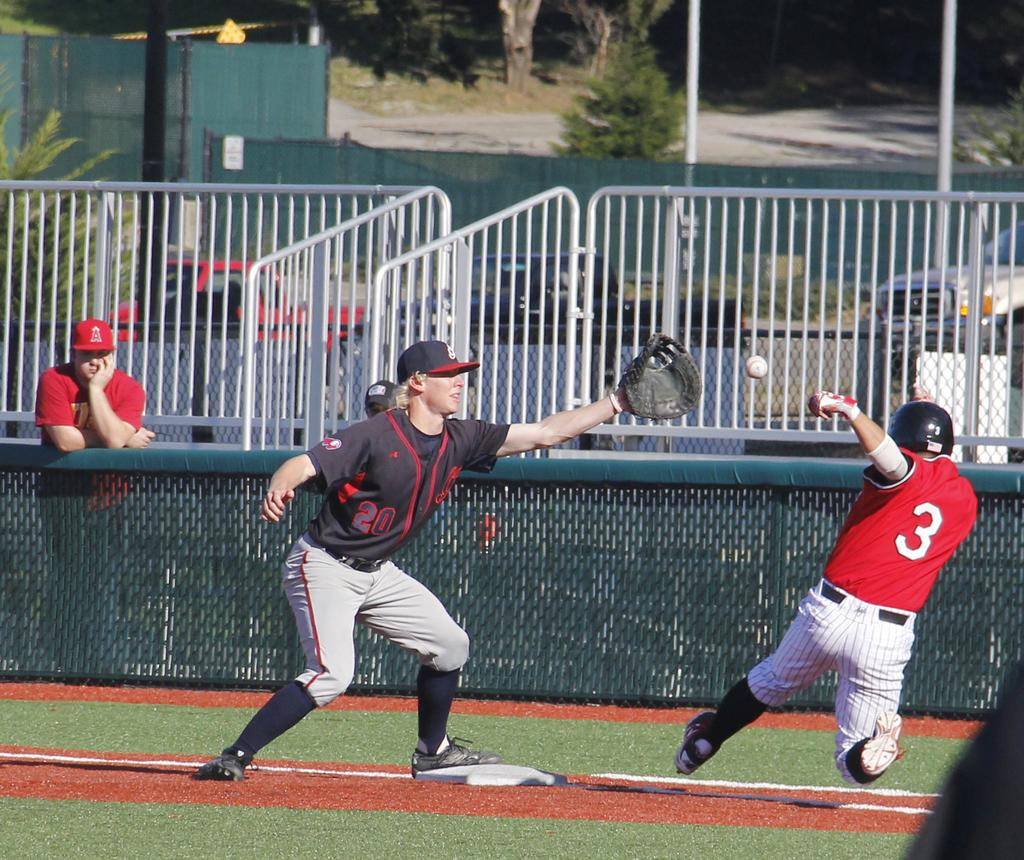<image>
Share a concise interpretation of the image provided. indians player #20 trying to get the ball before the angels player #3 gets to the base 